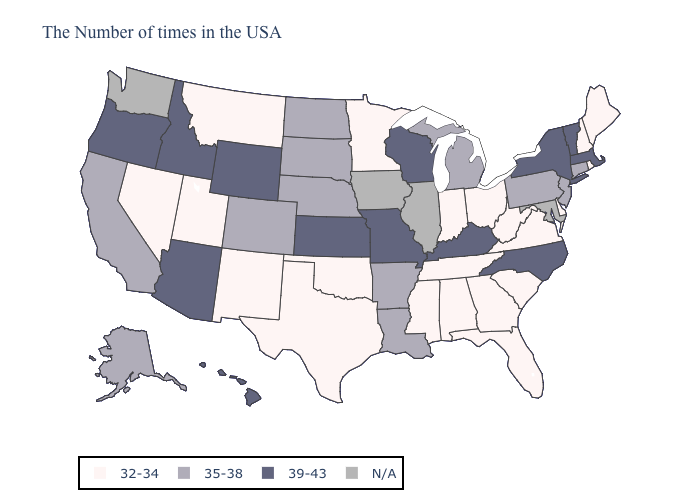Name the states that have a value in the range 32-34?
Concise answer only. Maine, Rhode Island, New Hampshire, Delaware, Virginia, South Carolina, West Virginia, Ohio, Florida, Georgia, Indiana, Alabama, Tennessee, Mississippi, Minnesota, Oklahoma, Texas, New Mexico, Utah, Montana, Nevada. Which states hav the highest value in the West?
Write a very short answer. Wyoming, Arizona, Idaho, Oregon, Hawaii. Does Montana have the highest value in the West?
Give a very brief answer. No. Name the states that have a value in the range N/A?
Keep it brief. Maryland, Illinois, Iowa, Washington. Name the states that have a value in the range N/A?
Quick response, please. Maryland, Illinois, Iowa, Washington. Among the states that border New York , which have the highest value?
Short answer required. Massachusetts, Vermont. How many symbols are there in the legend?
Short answer required. 4. Among the states that border Louisiana , does Arkansas have the lowest value?
Be succinct. No. What is the highest value in the USA?
Give a very brief answer. 39-43. Does the first symbol in the legend represent the smallest category?
Write a very short answer. Yes. Does the map have missing data?
Give a very brief answer. Yes. Name the states that have a value in the range N/A?
Quick response, please. Maryland, Illinois, Iowa, Washington. Does the map have missing data?
Quick response, please. Yes. Name the states that have a value in the range 35-38?
Write a very short answer. Connecticut, New Jersey, Pennsylvania, Michigan, Louisiana, Arkansas, Nebraska, South Dakota, North Dakota, Colorado, California, Alaska. Name the states that have a value in the range 32-34?
Short answer required. Maine, Rhode Island, New Hampshire, Delaware, Virginia, South Carolina, West Virginia, Ohio, Florida, Georgia, Indiana, Alabama, Tennessee, Mississippi, Minnesota, Oklahoma, Texas, New Mexico, Utah, Montana, Nevada. 